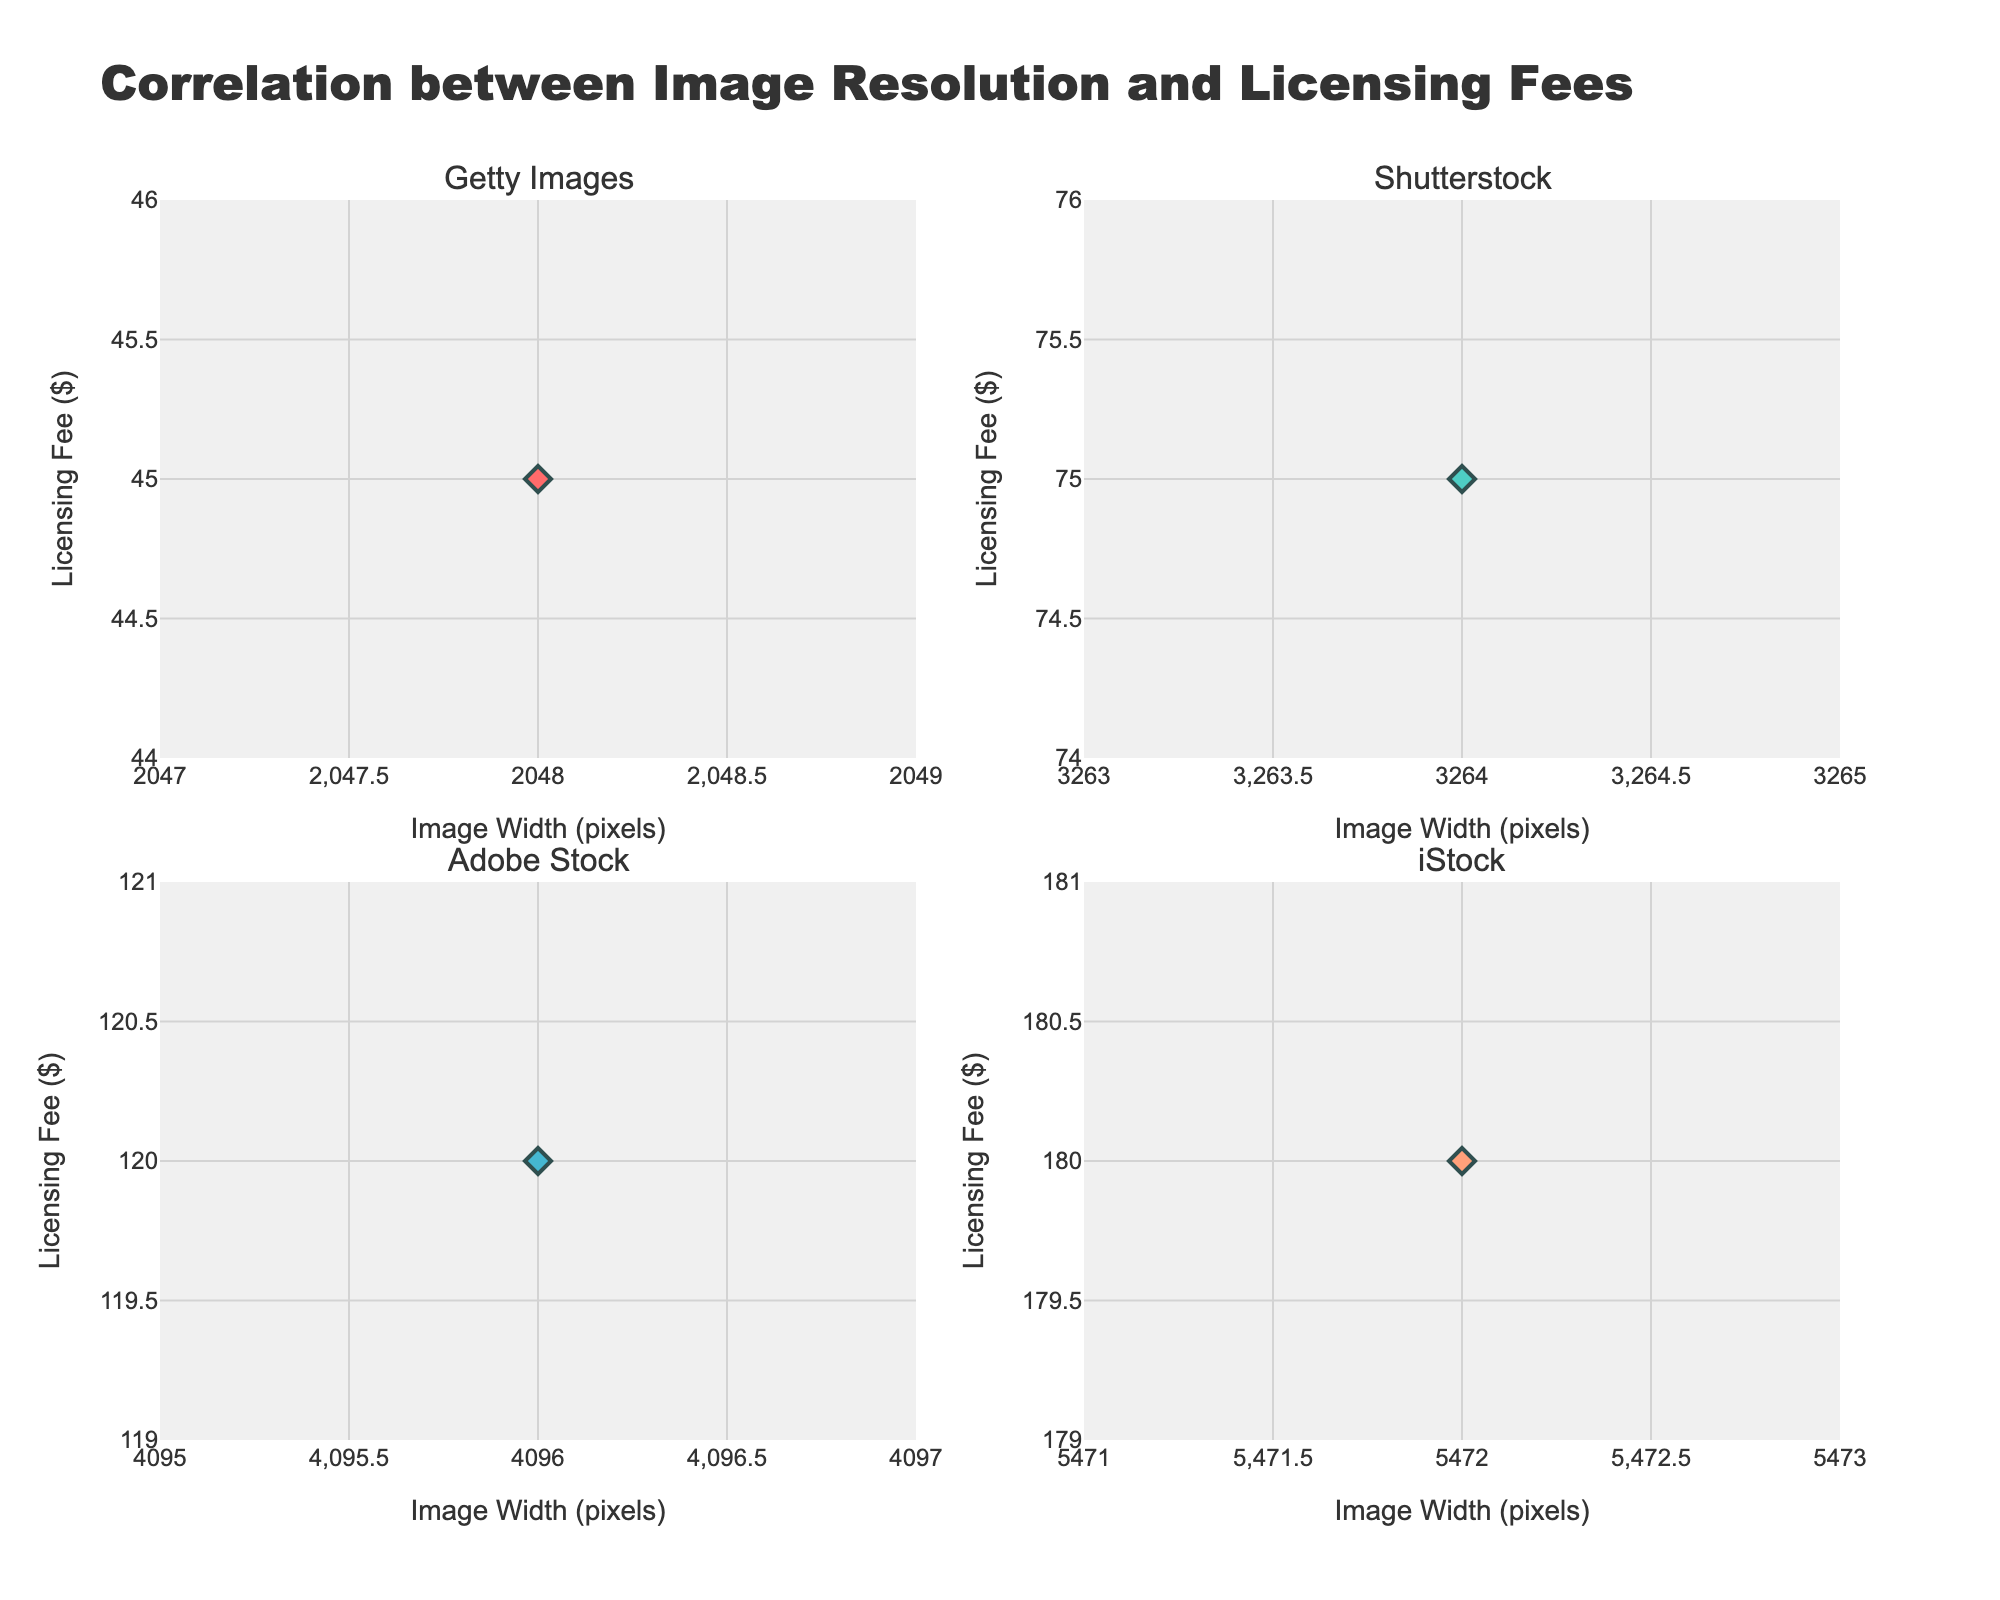What is the title of the figure? The title is typically displayed prominently at the top of the plot. In this case, it specifically describes the main focus of the figure which is the correlation.
Answer: Correlation between Image Resolution and Licensing Fees How many platforms are shown in the subplots? The subplot titles usually indicate the different groups or categories being compared. By counting these titles, the number of platforms can be determined.
Answer: 4 Which platform has the highest licensing fee in the scatter plots shown? Look at the y-axis values for all subplots and identify the highest data point. Each subplot represents a different platform, enabling a comparison.
Answer: iStock What is the licensing fee for Getty Images at the highest resolution available? Identify the marker corresponding to the highest x-axis value in the Getty Images subplot and check its y-axis value.
Answer: 45 Compare the licensing fee range for Getty Images and Shutterstock. Which one has a broader range? Determine the range by finding the difference between the highest and lowest data points on the y-axis for both platforms and compare them.
Answer: Shutterstock Which subplot shows the strongest correlation between image resolution and licensing fees? Correlation strength can often be visually estimated by seeing how closely the points follow a line. Identify which subplot's points are most tightly clustered in a linear trend.
Answer: iStock What is the average licensing fee for the displayed data points in the Adobe Stock subplot? Add all the licensing fees for Adobe Stock and divide by the number of data points shown. As there's only one data point, the value itself is the average.
Answer: 120 Does iStock show more expensive or cheaper licensing fees compared to Adobe Stock? Compare the licensing fees shown in both subplots directly.
Answer: More expensive How does the image width (pixels) affect the licensing fee for Getty Images based on the subplot? Observe the trend of the scatter points for Getty Images; note if there's an increasing, decreasing, or no clear trend.
Answer: Increasing trend 